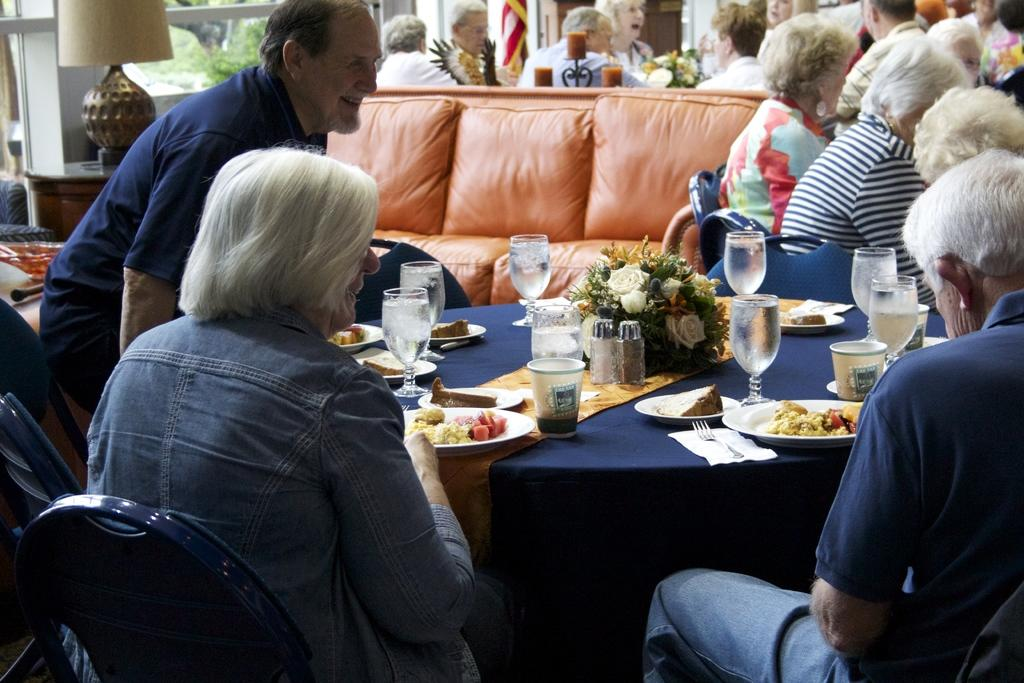What are the people in the image doing? The persons in the image are sitting on chairs. What type of furniture is present in the image besides chairs? There is a couch in the image. What items can be seen on the table? There are glasses, flowers, plates, food, and a lantern lamp on the table. Where is the flag located in the image? The flag is far from the table in the image. What type of pie is being served on the train in the image? There is no train or pie present in the image; it features persons sitting on chairs, a couch, a table with various items, and a flag far from the table. 